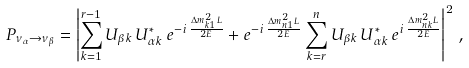<formula> <loc_0><loc_0><loc_500><loc_500>P _ { \nu _ { \alpha } \to \nu _ { \beta } } = \left | \sum _ { k = 1 } ^ { r - 1 } U _ { { \beta } k } \, U _ { { \alpha } k } ^ { * } \, e ^ { - i \, \frac { \Delta { m } ^ { 2 } _ { k 1 } L } { 2 E } } + e ^ { - i \, \frac { \Delta { m } ^ { 2 } _ { n 1 } L } { 2 E } } \sum _ { k = r } ^ { n } U _ { { \beta } k } \, U _ { { \alpha } k } ^ { * } \, e ^ { i \, \frac { \Delta { m } ^ { 2 } _ { n k } L } { 2 E } } \right | ^ { 2 } \, ,</formula> 